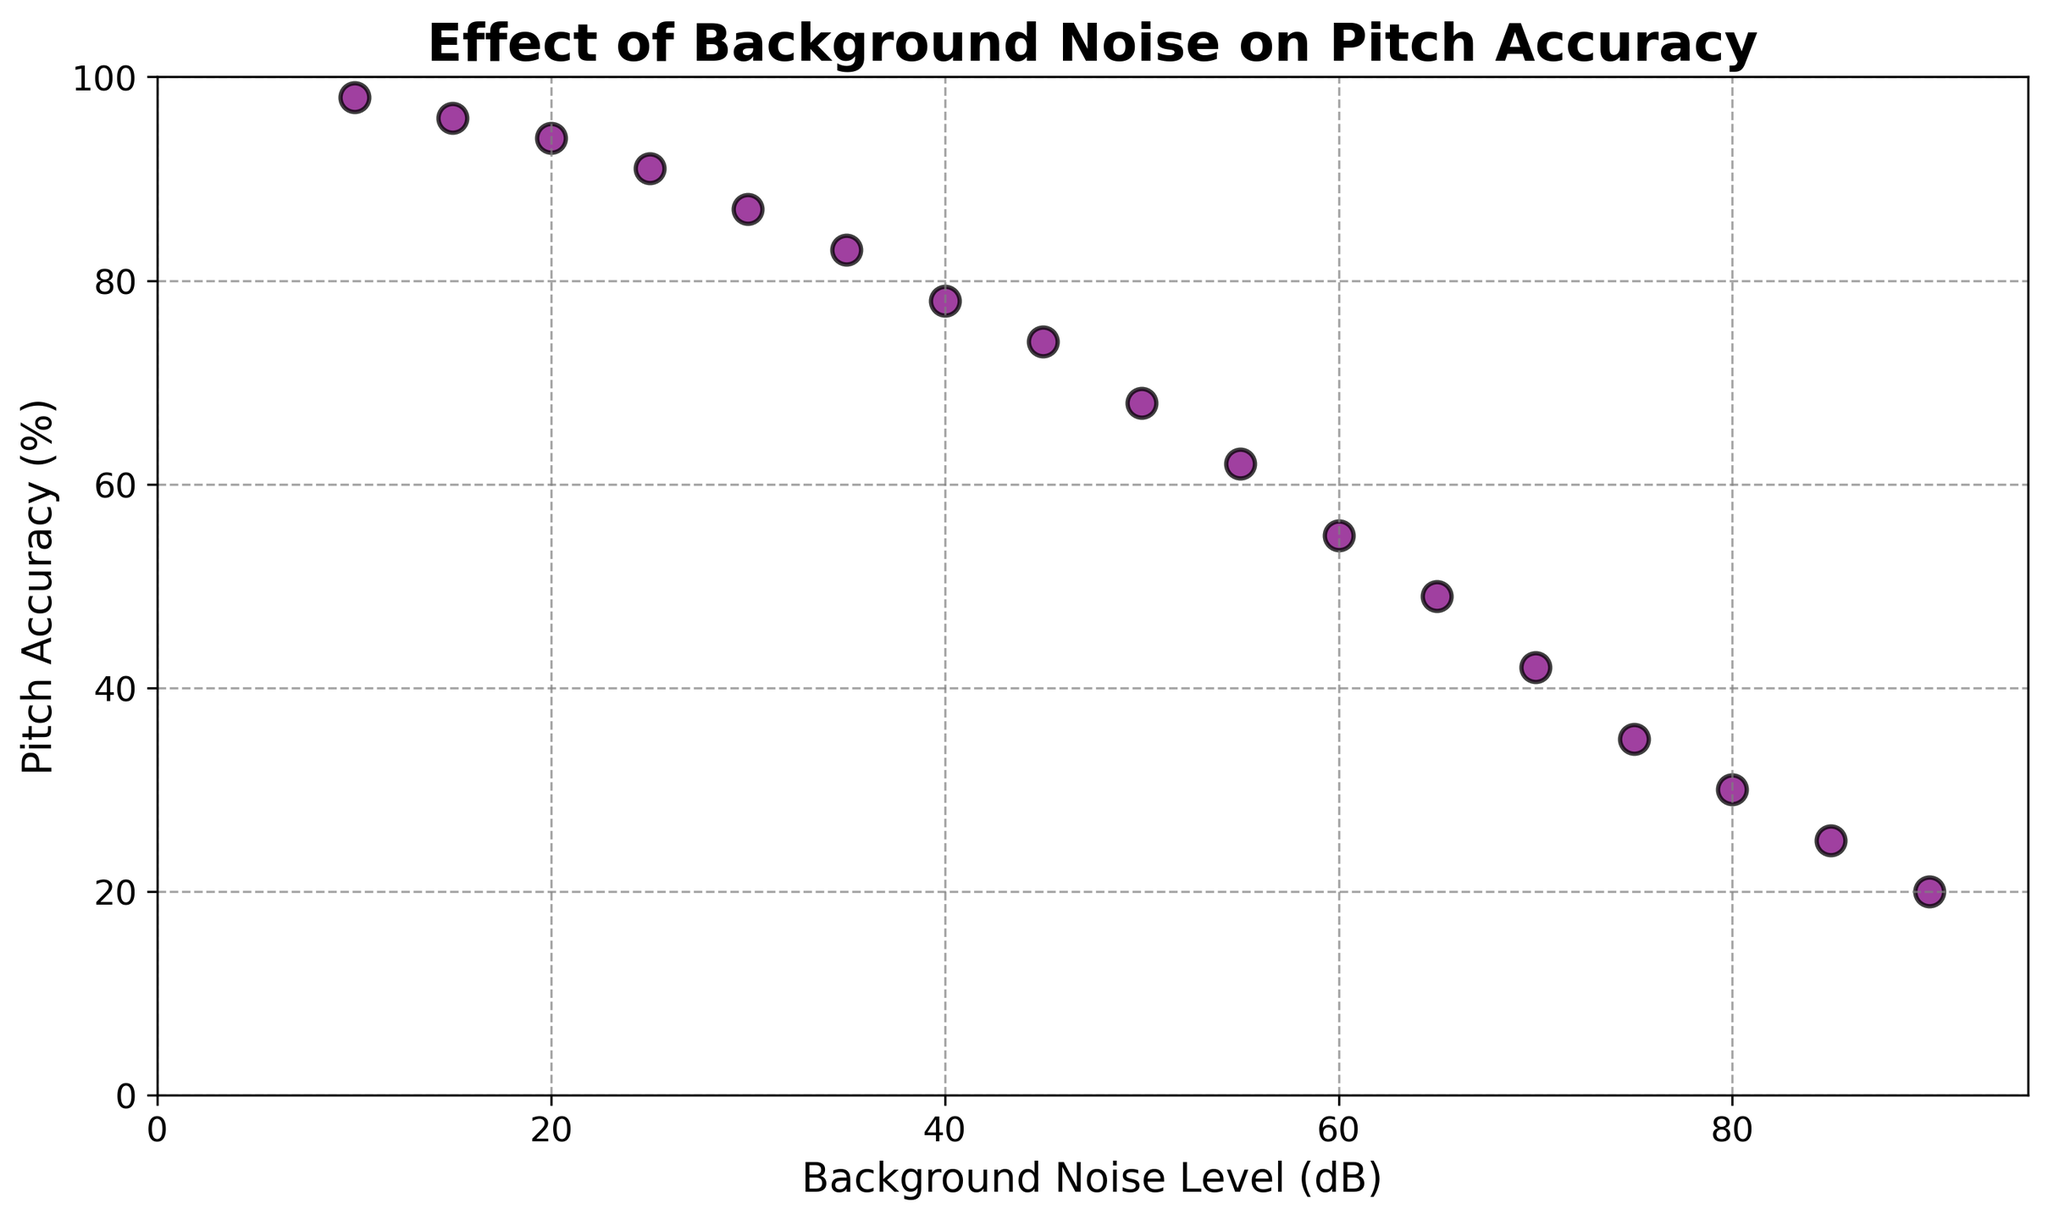Does pitch accuracy increase or decrease with higher levels of background noise? As the points in the scatter plot show, the trend line slopes downward from left to right. This indicates that pitch accuracy decreases as the background noise level increases.
Answer: Decreases What is the pitch accuracy percentage when the background noise level is 50 dB? Locate the data point along the x-axis where the background noise level is 50 dB and check the corresponding value on the y-axis. The data point at 50 dB matches to 68% pitch accuracy.
Answer: 68% Which background noise level shows the most significant drop in pitch accuracy, and what percent does it decrease to? Identify the steepest decline between two consecutive data points in the scatter plot. The most significant drop occurs between 10 dB (98%) and 20 dB (94%), with a 4% decrease.
Answer: Between 10 dB and 20 dB, decreases to 94% Between which two noise levels does pitch accuracy drop below 50%? To find out where pitch accuracy drops below 50%, locate the data points on the y-axis below 50%. The transition happens between 60 dB (55%) and 65 dB (49%).
Answer: Between 60 dB and 65 dB What is the average pitch accuracy percentage for background noise levels above 40 dB? List the percentages for noise levels above 40 dB: 78%, 74%, 68%, 62%, 55%, 49%, 42%, 35%, 30%, 25%, 20%. Sum these values: 78 + 74 + 68 + 62 + 55 + 49 + 42 + 35 + 30 + 25 + 20 = 538. Divide by the number of values (11).
Answer: 48.9% How much does pitch accuracy decline when background noise increases from 25 dB to 75 dB? Find the pitch accuracy at 25 dB (91%) and at 75 dB (35%). Calculate the difference: 91% - 35% = 56%.
Answer: 56% What is the visual pattern of the scatter plot points relating to background noise and pitch accuracy? The scatter plot shows a negative correlation where data points slope downward from left to right. Each increment in noise level correlates with a consistent drop in pitch accuracy.
Answer: Negative correlation Which background noise level shows a pitch accuracy of at least 80%? Look at the y-axis for data points at or above 80%, followed by checking the corresponding x-axis. The noise levels 10 dB and 15 dB show pitch accuracy of 98% and 96%, respectively.
Answer: 10 dB and 15 dB Is there a linear relationship between background noise level and pitch accuracy? Observing the scatter plot, data points form a downward-sloping trend line, indicating a negative linear relationship.
Answer: Yes 